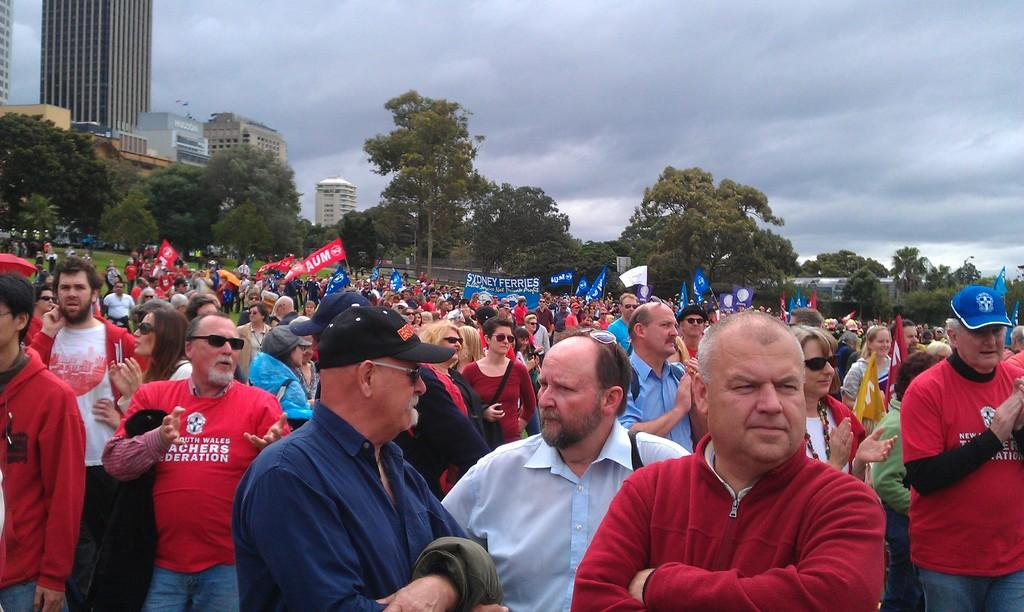How many people are in the image? There is a group of people in the image, but the exact number cannot be determined from the provided facts. What can be seen in the background of the image? In the background of the image, there are banners, flags, buildings, trees, and the sky. What type of structures are visible in the background? Buildings are visible in the background of the image. What is the color of the sky in the image? The sky is visible in the background of the image, but the color cannot be determined from the provided facts. What type of cup is being used to form an argument in the image? There is no cup or argument present in the image. 